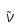Convert formula to latex. <formula><loc_0><loc_0><loc_500><loc_500>\tilde { \nu }</formula> 